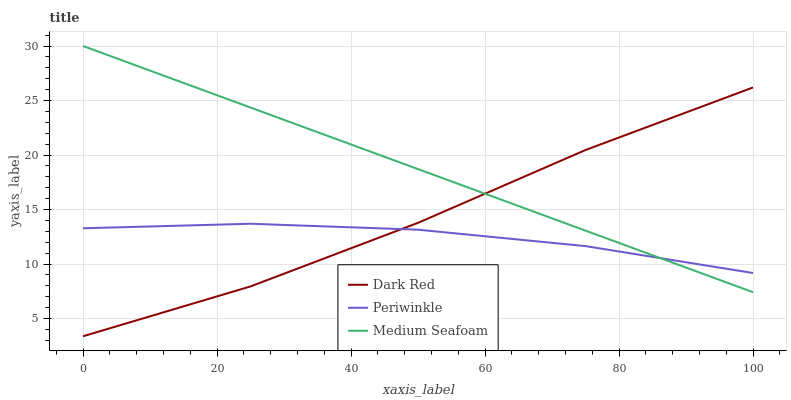Does Periwinkle have the minimum area under the curve?
Answer yes or no. Yes. Does Medium Seafoam have the maximum area under the curve?
Answer yes or no. Yes. Does Medium Seafoam have the minimum area under the curve?
Answer yes or no. No. Does Periwinkle have the maximum area under the curve?
Answer yes or no. No. Is Medium Seafoam the smoothest?
Answer yes or no. Yes. Is Dark Red the roughest?
Answer yes or no. Yes. Is Periwinkle the smoothest?
Answer yes or no. No. Is Periwinkle the roughest?
Answer yes or no. No. Does Dark Red have the lowest value?
Answer yes or no. Yes. Does Medium Seafoam have the lowest value?
Answer yes or no. No. Does Medium Seafoam have the highest value?
Answer yes or no. Yes. Does Periwinkle have the highest value?
Answer yes or no. No. Does Periwinkle intersect Medium Seafoam?
Answer yes or no. Yes. Is Periwinkle less than Medium Seafoam?
Answer yes or no. No. Is Periwinkle greater than Medium Seafoam?
Answer yes or no. No. 